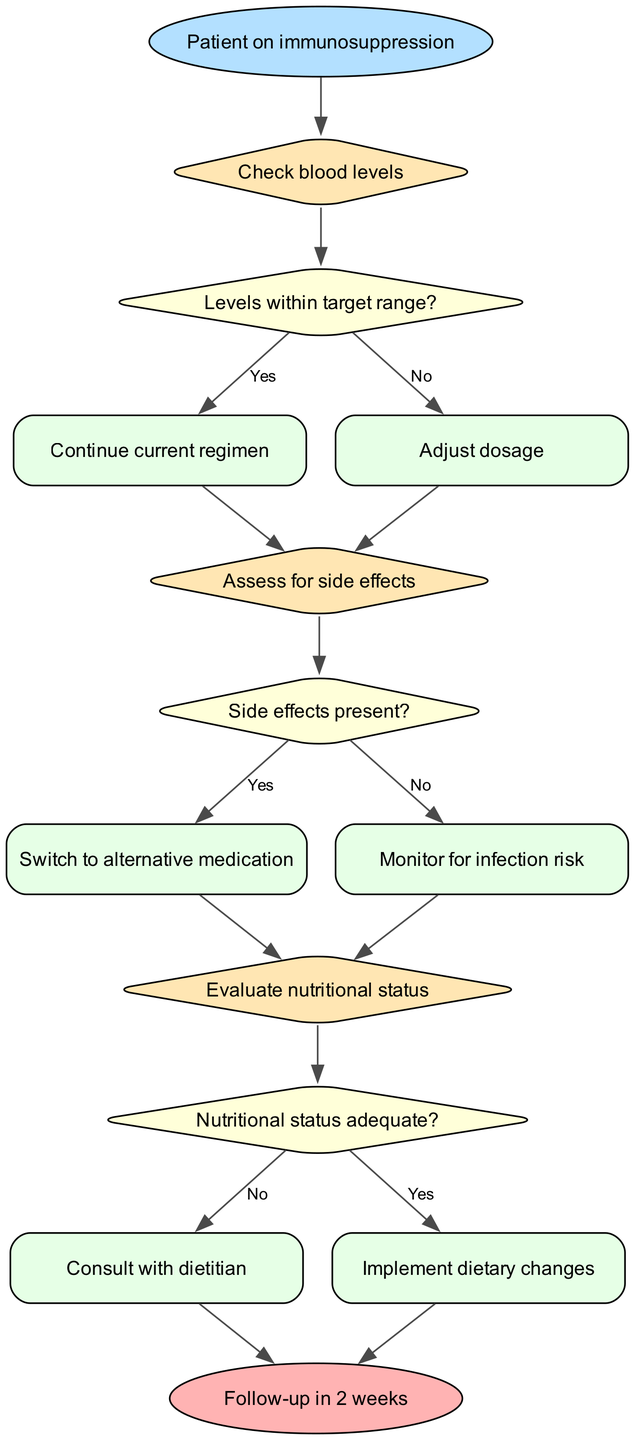What is the starting point of the flowchart? The starting point of the flowchart is the node labeled "Patient on immunosuppression." This is clearly indicated as the first step in the flowchart.
Answer: Patient on immunosuppression How many decision nodes are present in the diagram? The diagram contains three decision nodes: "Check blood levels," "Assess for side effects," and "Evaluate nutritional status." This can be counted directly from the flowchart structure.
Answer: 3 What action is taken if blood levels are within the target range? If blood levels are within the target range, the action taken is to "Continue current regimen," which follows directly from the condition linked to the "Check blood levels" decision.
Answer: Continue current regimen What happens if side effects are present? If side effects are present, the flowchart dictates that the action is to "Switch to alternative medication," as indicated from the "Assess for side effects" decision node leading to this action.
Answer: Switch to alternative medication What is the action taken when nutritional status is adequate? When the nutritional status is adequate, the action is to "Implement dietary changes," which is the outcome following the evaluation at the "Evaluate nutritional status" decision node.
Answer: Implement dietary changes How do you determine what to do if the nutritional status is not adequate? If the nutritional status is not adequate, the flowchart specifies that the action is to "Consult with dietitian," which directly follows the negative outcome of the "Evaluate nutritional status" decision.
Answer: Consult with dietitian What is the follow-up timeframe indicated in the diagram? The follow-up timeframe indicated in the diagram is "Follow-up in 2 weeks," which is the concluding action leading to the end of the flowchart.
Answer: Follow-up in 2 weeks If blood levels are not within range, what is the next step? If blood levels are not within the target range, the next step is to "Adjust dosage," as indicated by the path leading from the decision regarding blood levels.
Answer: Adjust dosage 